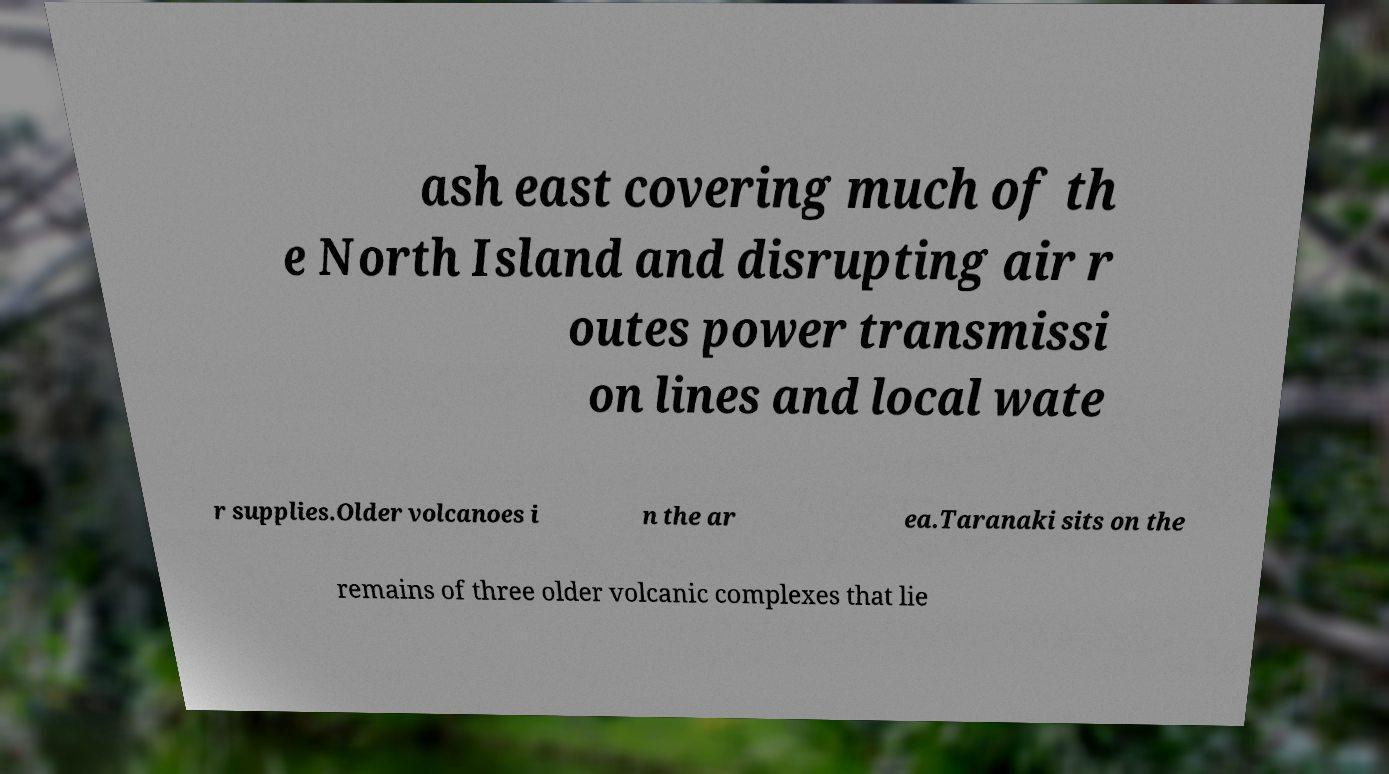Could you assist in decoding the text presented in this image and type it out clearly? ash east covering much of th e North Island and disrupting air r outes power transmissi on lines and local wate r supplies.Older volcanoes i n the ar ea.Taranaki sits on the remains of three older volcanic complexes that lie 